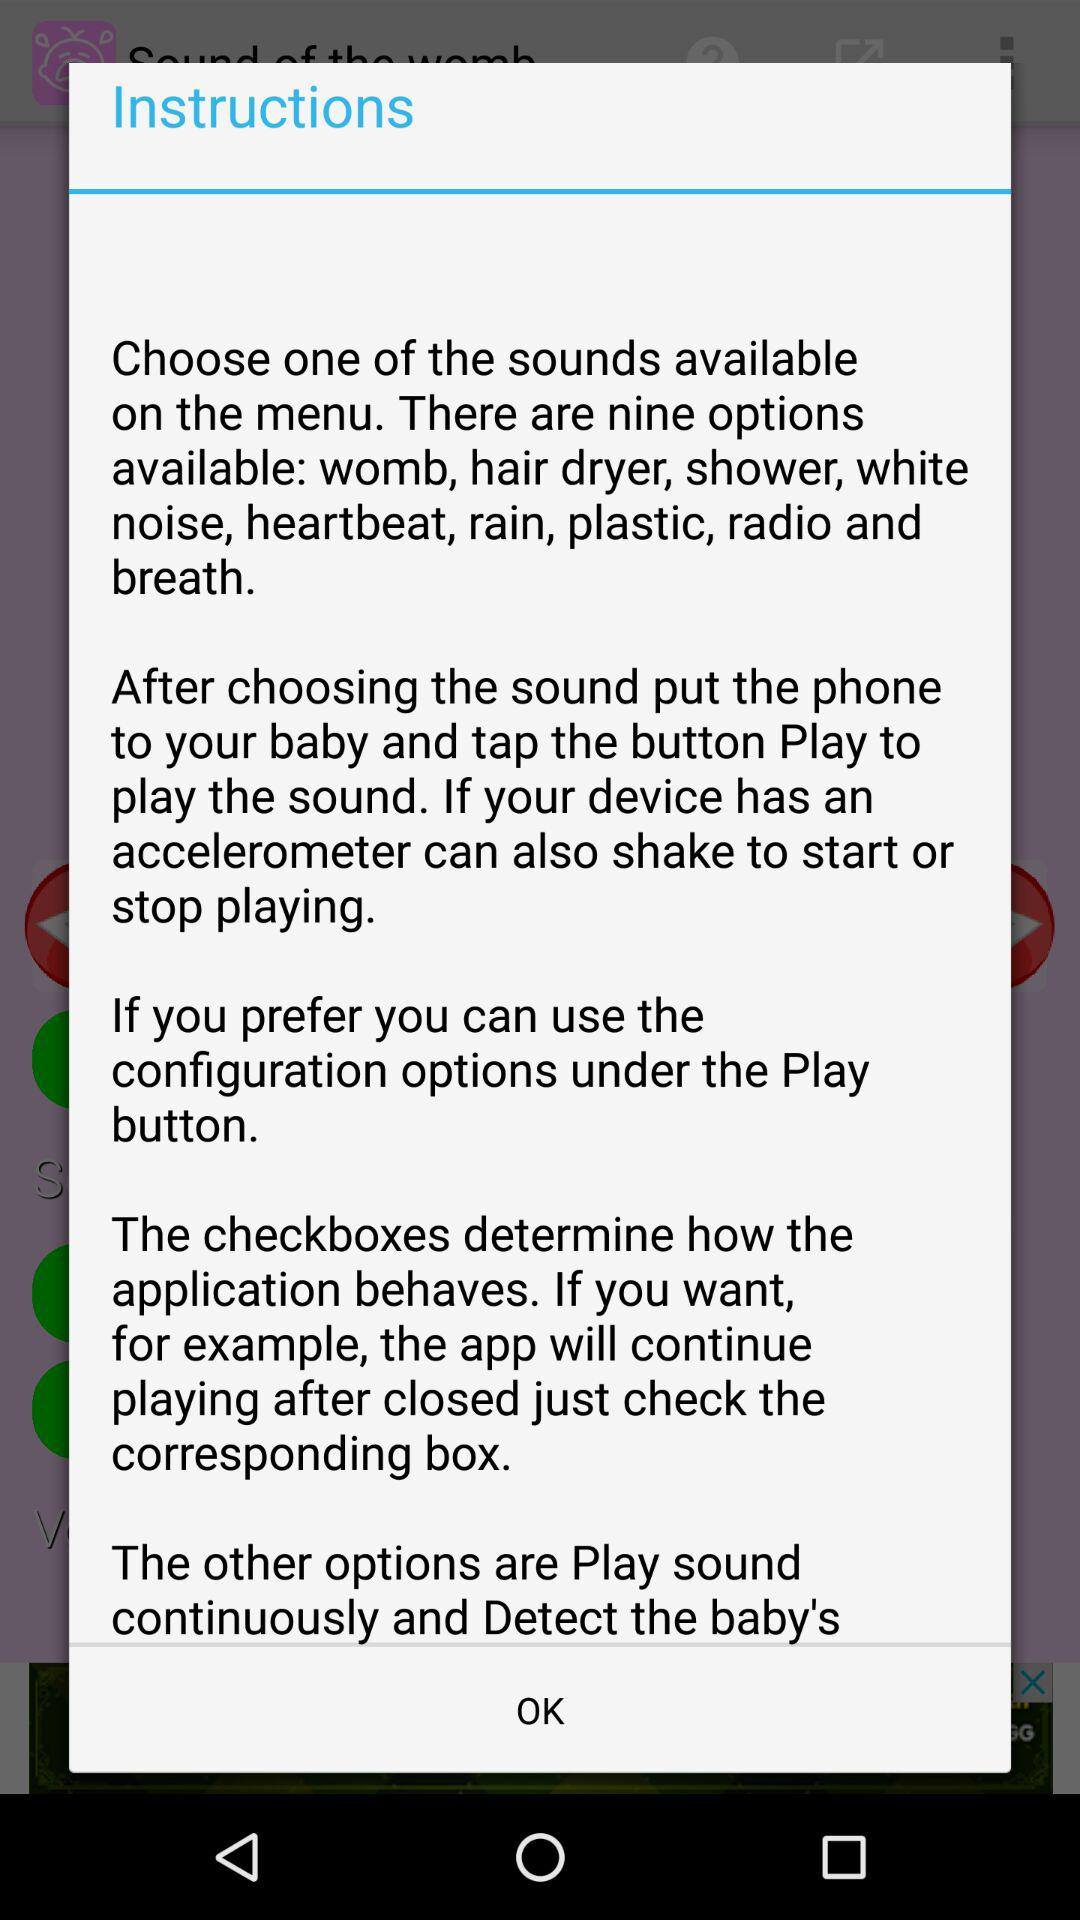How many options are available to choose from in the menu?
Answer the question using a single word or phrase. 9 